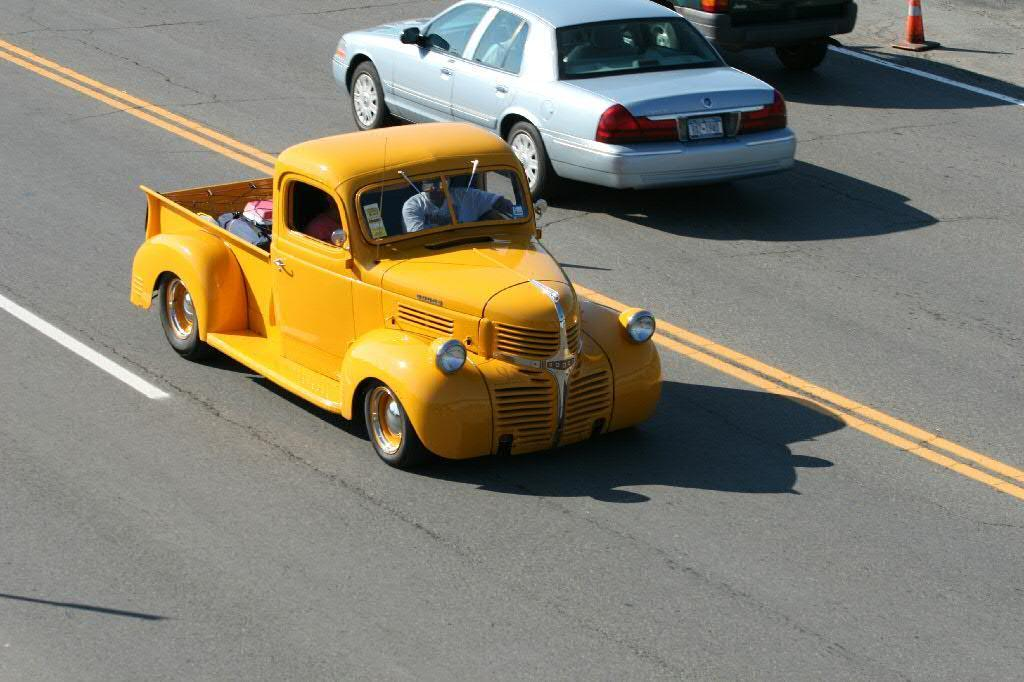What is happening on the road in the image? Cars are moving on the road in the image. Can you describe any specific car in the image? There is a yellow car in the image. What part of the image shows the road? The road is visible at the bottom of the image. What type of wire or cord can be seen hanging from the door in the image? There is no wire, cord, or door present in the image. 